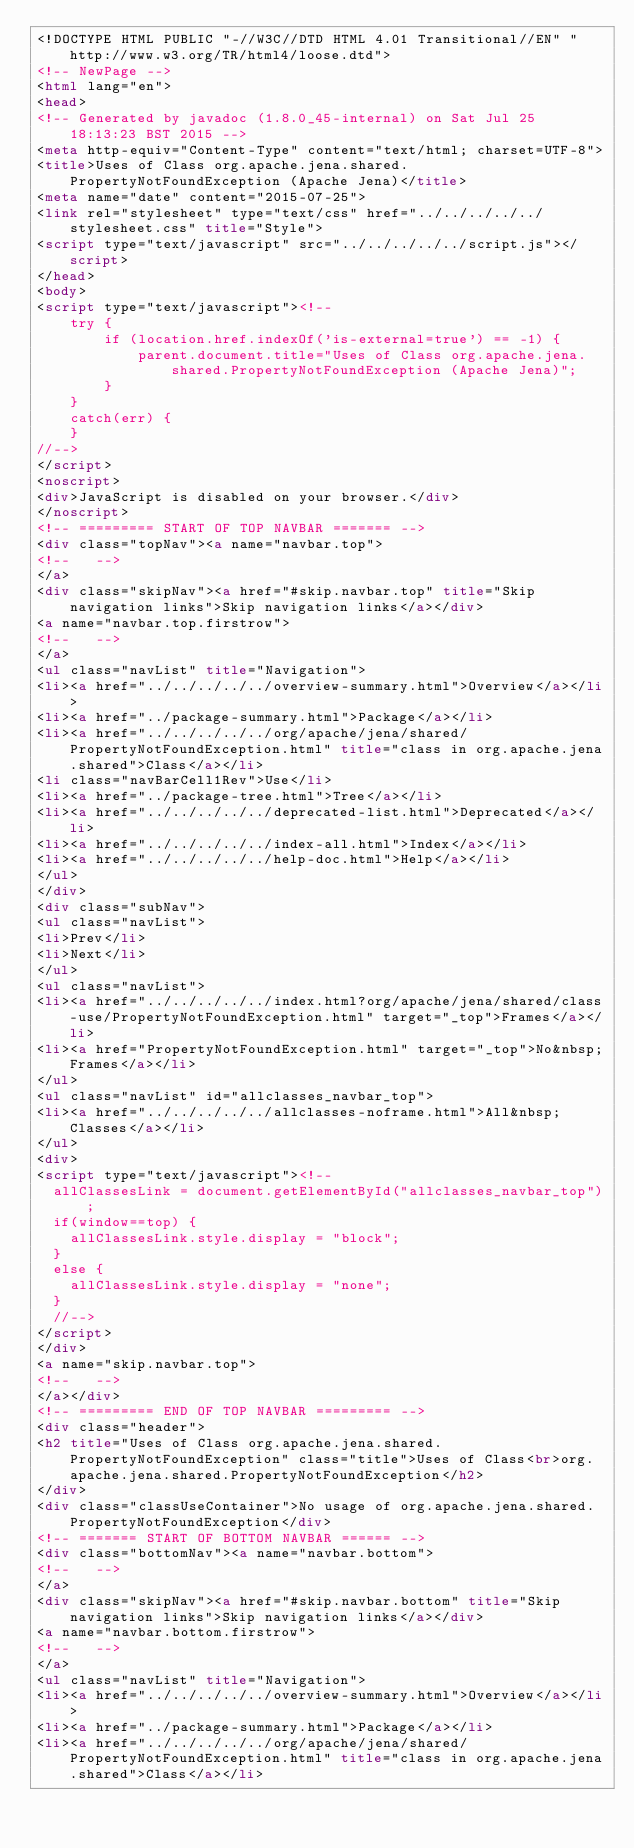<code> <loc_0><loc_0><loc_500><loc_500><_HTML_><!DOCTYPE HTML PUBLIC "-//W3C//DTD HTML 4.01 Transitional//EN" "http://www.w3.org/TR/html4/loose.dtd">
<!-- NewPage -->
<html lang="en">
<head>
<!-- Generated by javadoc (1.8.0_45-internal) on Sat Jul 25 18:13:23 BST 2015 -->
<meta http-equiv="Content-Type" content="text/html; charset=UTF-8">
<title>Uses of Class org.apache.jena.shared.PropertyNotFoundException (Apache Jena)</title>
<meta name="date" content="2015-07-25">
<link rel="stylesheet" type="text/css" href="../../../../../stylesheet.css" title="Style">
<script type="text/javascript" src="../../../../../script.js"></script>
</head>
<body>
<script type="text/javascript"><!--
    try {
        if (location.href.indexOf('is-external=true') == -1) {
            parent.document.title="Uses of Class org.apache.jena.shared.PropertyNotFoundException (Apache Jena)";
        }
    }
    catch(err) {
    }
//-->
</script>
<noscript>
<div>JavaScript is disabled on your browser.</div>
</noscript>
<!-- ========= START OF TOP NAVBAR ======= -->
<div class="topNav"><a name="navbar.top">
<!--   -->
</a>
<div class="skipNav"><a href="#skip.navbar.top" title="Skip navigation links">Skip navigation links</a></div>
<a name="navbar.top.firstrow">
<!--   -->
</a>
<ul class="navList" title="Navigation">
<li><a href="../../../../../overview-summary.html">Overview</a></li>
<li><a href="../package-summary.html">Package</a></li>
<li><a href="../../../../../org/apache/jena/shared/PropertyNotFoundException.html" title="class in org.apache.jena.shared">Class</a></li>
<li class="navBarCell1Rev">Use</li>
<li><a href="../package-tree.html">Tree</a></li>
<li><a href="../../../../../deprecated-list.html">Deprecated</a></li>
<li><a href="../../../../../index-all.html">Index</a></li>
<li><a href="../../../../../help-doc.html">Help</a></li>
</ul>
</div>
<div class="subNav">
<ul class="navList">
<li>Prev</li>
<li>Next</li>
</ul>
<ul class="navList">
<li><a href="../../../../../index.html?org/apache/jena/shared/class-use/PropertyNotFoundException.html" target="_top">Frames</a></li>
<li><a href="PropertyNotFoundException.html" target="_top">No&nbsp;Frames</a></li>
</ul>
<ul class="navList" id="allclasses_navbar_top">
<li><a href="../../../../../allclasses-noframe.html">All&nbsp;Classes</a></li>
</ul>
<div>
<script type="text/javascript"><!--
  allClassesLink = document.getElementById("allclasses_navbar_top");
  if(window==top) {
    allClassesLink.style.display = "block";
  }
  else {
    allClassesLink.style.display = "none";
  }
  //-->
</script>
</div>
<a name="skip.navbar.top">
<!--   -->
</a></div>
<!-- ========= END OF TOP NAVBAR ========= -->
<div class="header">
<h2 title="Uses of Class org.apache.jena.shared.PropertyNotFoundException" class="title">Uses of Class<br>org.apache.jena.shared.PropertyNotFoundException</h2>
</div>
<div class="classUseContainer">No usage of org.apache.jena.shared.PropertyNotFoundException</div>
<!-- ======= START OF BOTTOM NAVBAR ====== -->
<div class="bottomNav"><a name="navbar.bottom">
<!--   -->
</a>
<div class="skipNav"><a href="#skip.navbar.bottom" title="Skip navigation links">Skip navigation links</a></div>
<a name="navbar.bottom.firstrow">
<!--   -->
</a>
<ul class="navList" title="Navigation">
<li><a href="../../../../../overview-summary.html">Overview</a></li>
<li><a href="../package-summary.html">Package</a></li>
<li><a href="../../../../../org/apache/jena/shared/PropertyNotFoundException.html" title="class in org.apache.jena.shared">Class</a></li></code> 